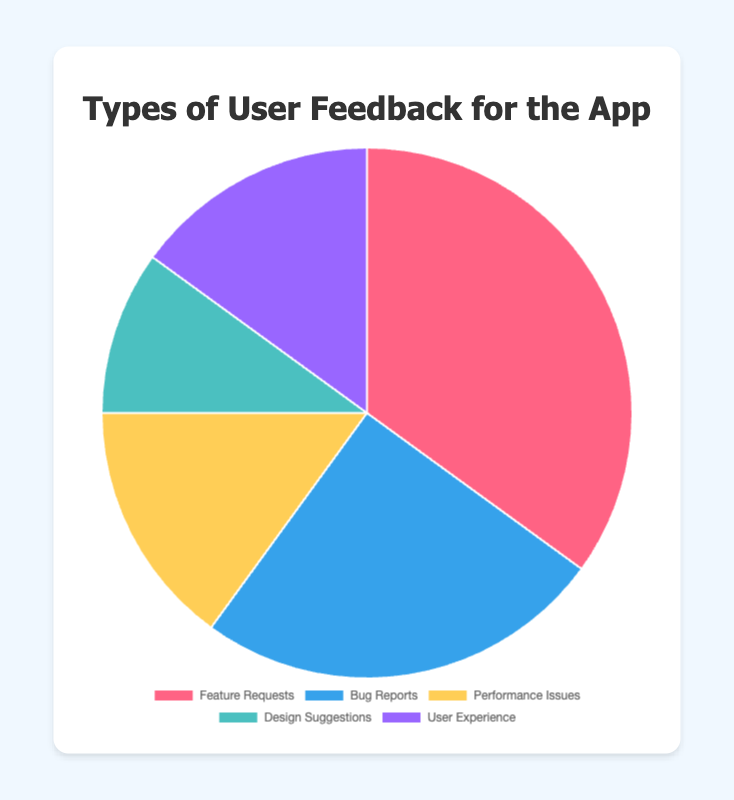Which type of user feedback has the highest percentage? Feature Requests have 35% of the total feedback, which is the highest among the feedback types.
Answer: Feature Requests Which two types of feedback are reported equally? Both Performance Issues and User Experience are shown to have 15%, meaning they are equal.
Answer: Performance Issues and User Experience What is the percentage difference between Feature Requests and Bug Reports? Feature Requests (35%) minus Bug Reports (25%) equals a 10% difference.
Answer: 10% What is the combined percentage of Design Suggestions and User Experience? Adding Design Suggestions (10%) to User Experience (15%) gives a total of 25%.
Answer: 25% Is the percentage of Bug Reports greater than or less than Performance Issues? Bug Reports (25%) is greater than Performance Issues (15%).
Answer: Greater What color represents Design Suggestions in the chart? The color representing Design Suggestions is light blue/aqua.
Answer: Light blue/aqua What is the ratio of Feature Requests to Bug Reports? The ratio is Feature Requests (35) divided by Bug Reports (25), which simplifies to 7:5.
Answer: 7:5 How many different types of feedback categories are there? There are five types of user feedback categories: Feature Requests, Bug Reports, Performance Issues, Design Suggestions, and User Experience.
Answer: 5 Which category has the lowest percentage and how much is it? Design Suggestions have the lowest percentage, which is 10%.
Answer: Design Suggestions, 10% Is the sum of Performance Issues and Bug Reports greater than Feature Requests? Performance Issues (15%) plus Bug Reports (25%) equals 40%, which is greater than Feature Requests (35%).
Answer: Yes, 40% 